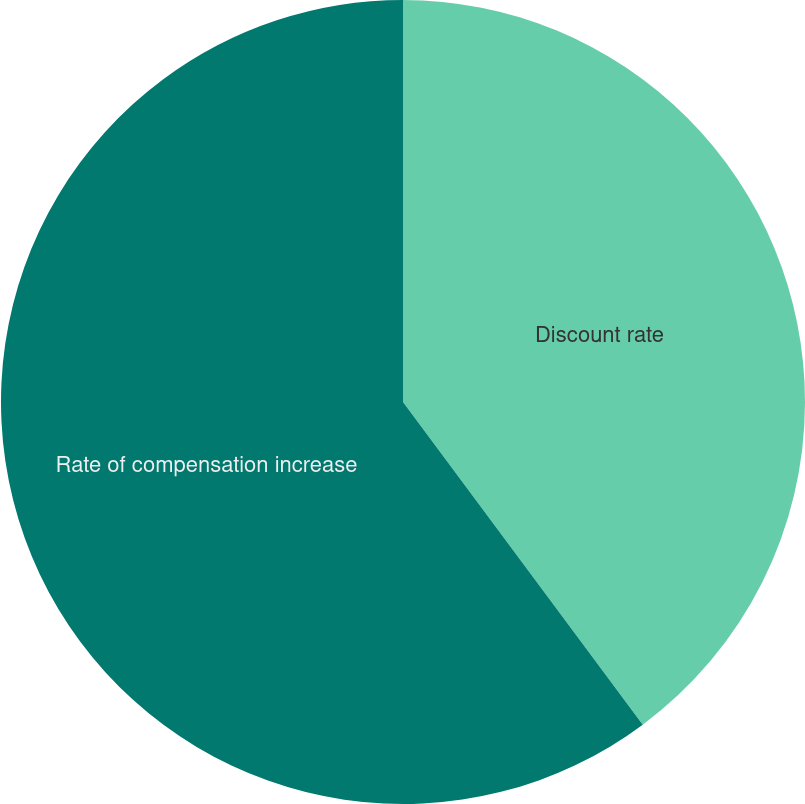<chart> <loc_0><loc_0><loc_500><loc_500><pie_chart><fcel>Discount rate<fcel>Rate of compensation increase<nl><fcel>39.83%<fcel>60.17%<nl></chart> 